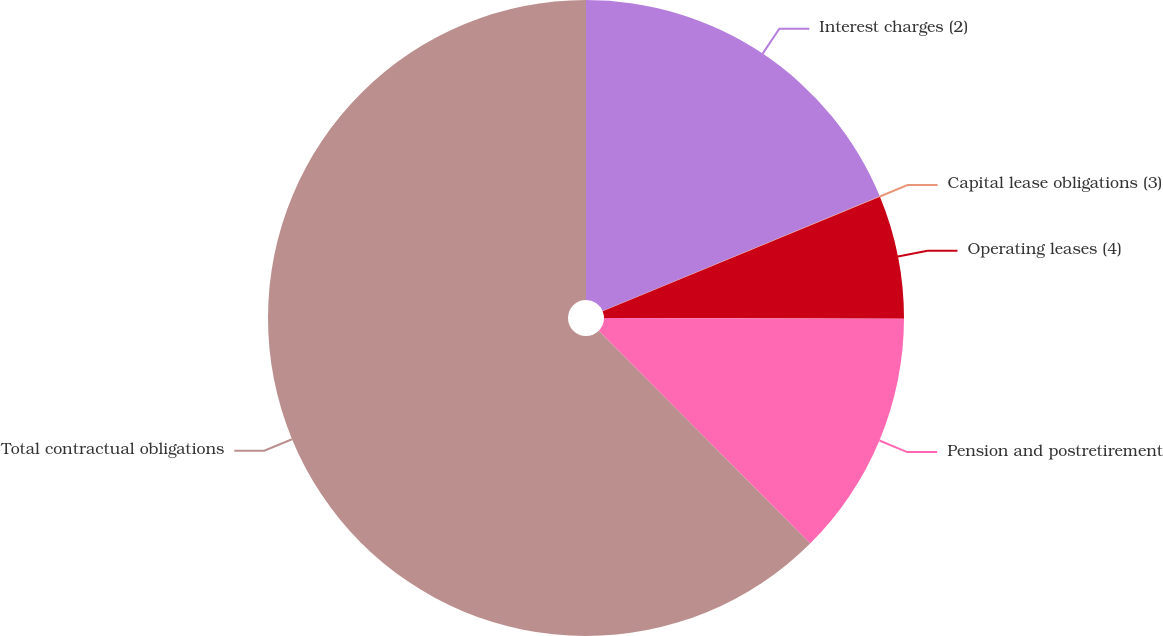Convert chart. <chart><loc_0><loc_0><loc_500><loc_500><pie_chart><fcel>Interest charges (2)<fcel>Capital lease obligations (3)<fcel>Operating leases (4)<fcel>Pension and postretirement<fcel>Total contractual obligations<nl><fcel>18.75%<fcel>0.02%<fcel>6.27%<fcel>12.51%<fcel>62.45%<nl></chart> 